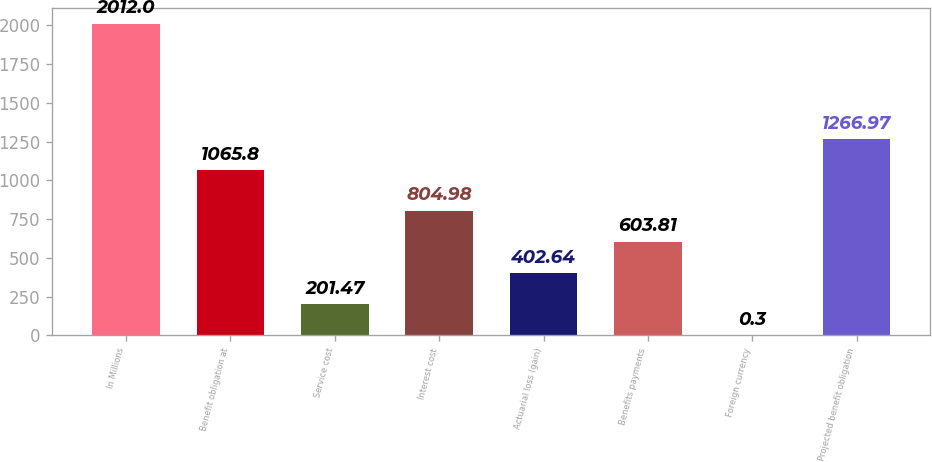Convert chart to OTSL. <chart><loc_0><loc_0><loc_500><loc_500><bar_chart><fcel>In Millions<fcel>Benefit obligation at<fcel>Service cost<fcel>Interest cost<fcel>Actuarial loss (gain)<fcel>Benefits payments<fcel>Foreign currency<fcel>Projected benefit obligation<nl><fcel>2012<fcel>1065.8<fcel>201.47<fcel>804.98<fcel>402.64<fcel>603.81<fcel>0.3<fcel>1266.97<nl></chart> 